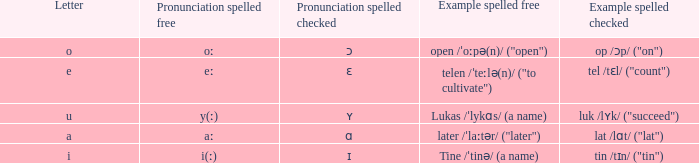What is Pronunciation Spelled Free, when Pronunciation Spelled Checked is "ɑ"? Aː. 